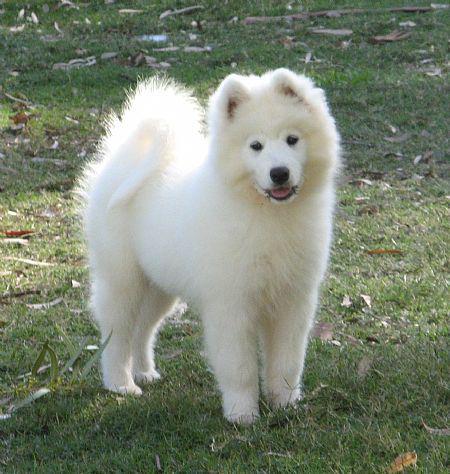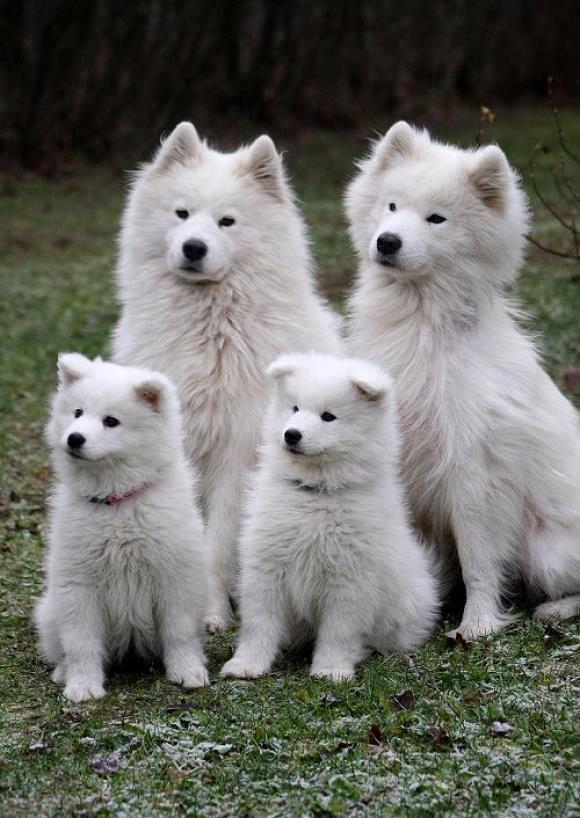The first image is the image on the left, the second image is the image on the right. Given the left and right images, does the statement "One of the images has two brown and white dogs in between two white dogs." hold true? Answer yes or no. No. The first image is the image on the left, the second image is the image on the right. For the images displayed, is the sentence "One image shows two white dogs sitting upright side-by-side, and the other image shows two sitting collies flanked by two sitting white dogs." factually correct? Answer yes or no. No. 